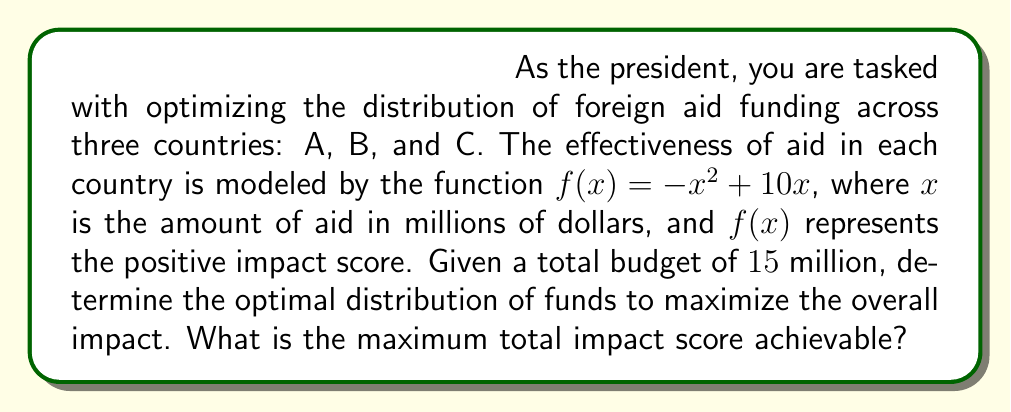Show me your answer to this math problem. To solve this optimization problem, we need to use calculus techniques:

1) Let $x$, $y$, and $z$ represent the amount of aid given to countries A, B, and C respectively.

2) Our objective is to maximize the total impact:
   $$F(x,y,z) = f(x) + f(y) + f(z) = (-x^2 + 10x) + (-y^2 + 10y) + (-z^2 + 10z)$$

3) Subject to the constraint: $x + y + z = 15$ (total budget)

4) We can use the method of Lagrange multipliers. Let's define:
   $$L(x,y,z,\lambda) = (-x^2 + 10x) + (-y^2 + 10y) + (-z^2 + 10z) + \lambda(15 - x - y - z)$$

5) Now, we set the partial derivatives equal to zero:
   $$\frac{\partial L}{\partial x} = -2x + 10 - \lambda = 0$$
   $$\frac{\partial L}{\partial y} = -2y + 10 - \lambda = 0$$
   $$\frac{\partial L}{\partial z} = -2z + 10 - \lambda = 0$$
   $$\frac{\partial L}{\partial \lambda} = 15 - x - y - z = 0$$

6) From the first three equations, we can see that $x = y = z$. Let's call this common value $a$.

7) Substituting into the fourth equation:
   $$15 - 3a = 0$$
   $$a = 5$$

8) Therefore, the optimal distribution is to give $5 million to each country.

9) The maximum total impact score is:
   $$F(5,5,5) = 3(-5^2 + 10(5)) = 3(25) = 75$$
Answer: The optimal distribution is $5 million to each country, achieving a maximum total impact score of 75. 